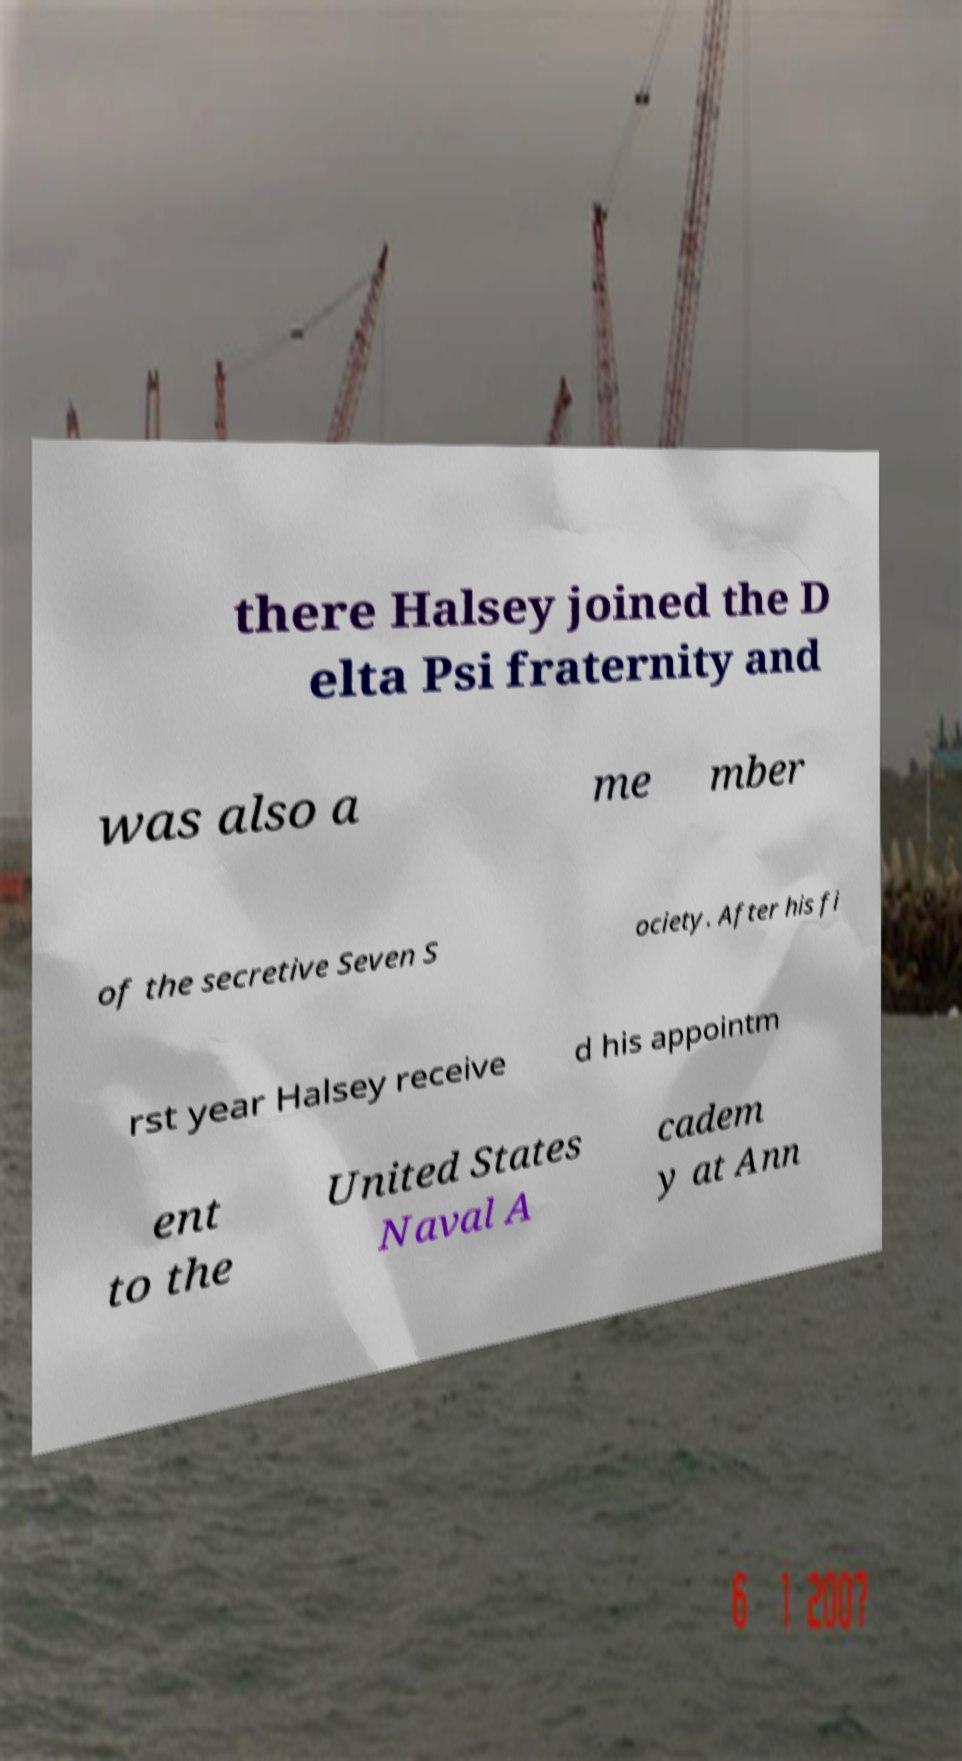I need the written content from this picture converted into text. Can you do that? there Halsey joined the D elta Psi fraternity and was also a me mber of the secretive Seven S ociety. After his fi rst year Halsey receive d his appointm ent to the United States Naval A cadem y at Ann 